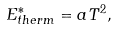<formula> <loc_0><loc_0><loc_500><loc_500>E ^ { * } _ { t h e r m } = a T ^ { 2 } ,</formula> 